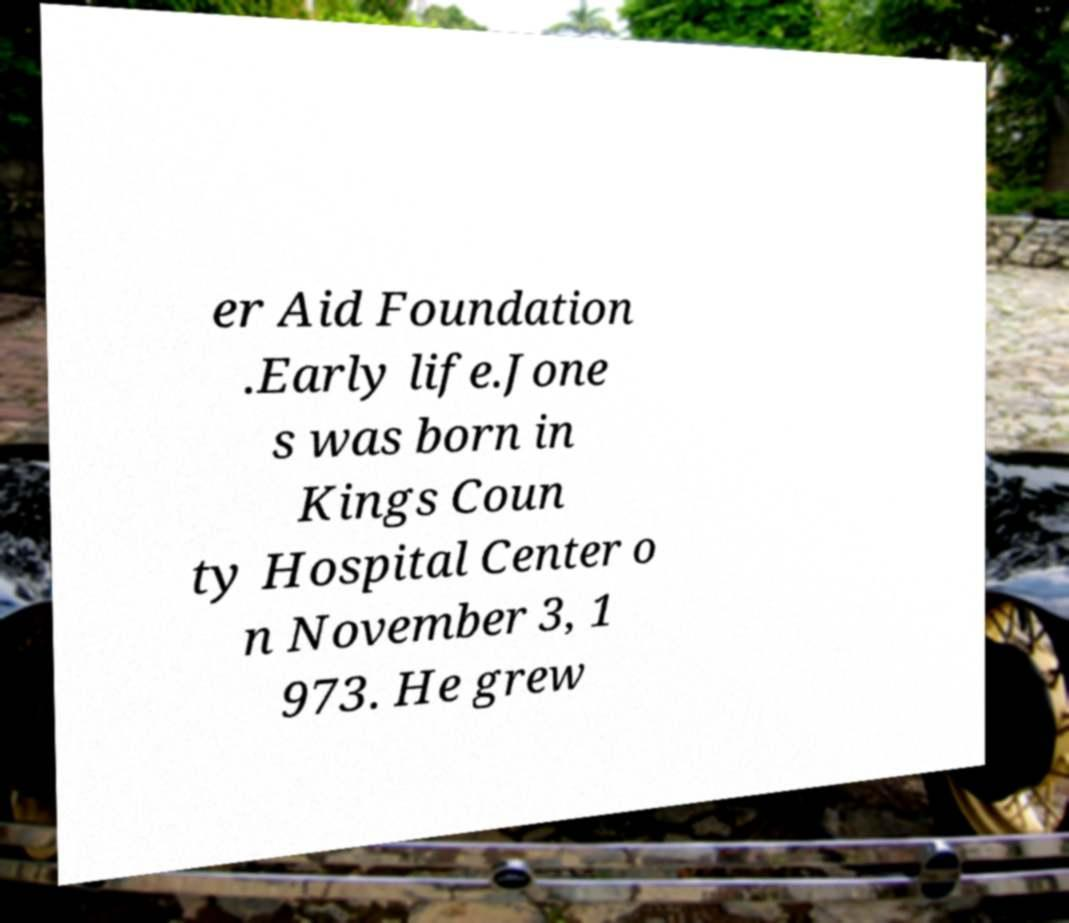Please identify and transcribe the text found in this image. er Aid Foundation .Early life.Jone s was born in Kings Coun ty Hospital Center o n November 3, 1 973. He grew 